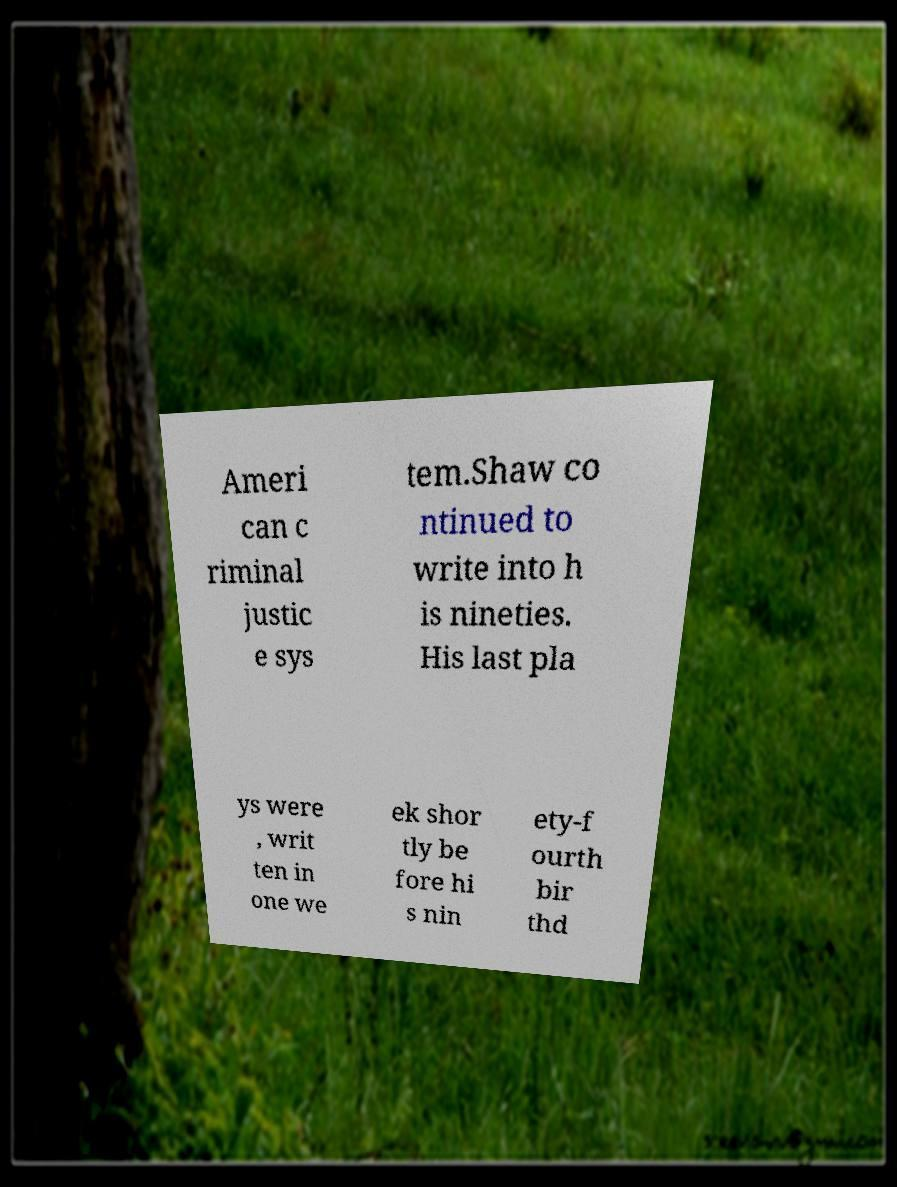I need the written content from this picture converted into text. Can you do that? Ameri can c riminal justic e sys tem.Shaw co ntinued to write into h is nineties. His last pla ys were , writ ten in one we ek shor tly be fore hi s nin ety-f ourth bir thd 